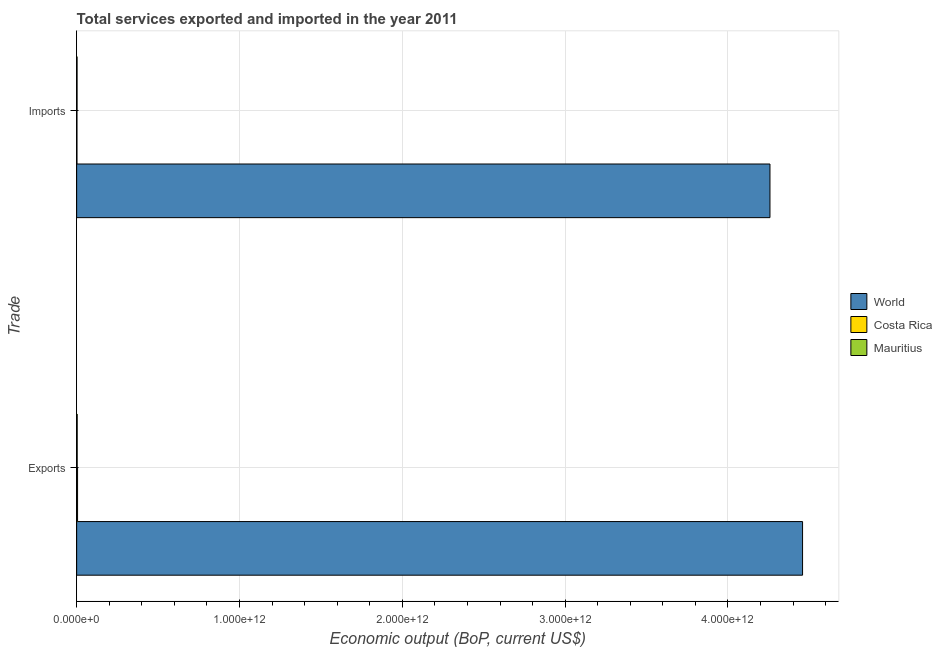Are the number of bars on each tick of the Y-axis equal?
Your response must be concise. Yes. How many bars are there on the 1st tick from the bottom?
Provide a short and direct response. 3. What is the label of the 1st group of bars from the top?
Provide a succinct answer. Imports. What is the amount of service imports in Costa Rica?
Your answer should be very brief. 1.82e+09. Across all countries, what is the maximum amount of service exports?
Ensure brevity in your answer.  4.46e+12. Across all countries, what is the minimum amount of service exports?
Your answer should be compact. 3.26e+09. In which country was the amount of service exports minimum?
Your answer should be very brief. Mauritius. What is the total amount of service exports in the graph?
Your response must be concise. 4.47e+12. What is the difference between the amount of service imports in Mauritius and that in Costa Rica?
Your answer should be compact. 6.49e+08. What is the difference between the amount of service exports in World and the amount of service imports in Mauritius?
Offer a terse response. 4.46e+12. What is the average amount of service imports per country?
Keep it short and to the point. 1.42e+12. What is the difference between the amount of service imports and amount of service exports in World?
Provide a succinct answer. -2.00e+11. In how many countries, is the amount of service imports greater than 4000000000000 US$?
Ensure brevity in your answer.  1. What is the ratio of the amount of service imports in World to that in Mauritius?
Offer a very short reply. 1723.81. In how many countries, is the amount of service exports greater than the average amount of service exports taken over all countries?
Make the answer very short. 1. What does the 2nd bar from the top in Imports represents?
Keep it short and to the point. Costa Rica. What does the 3rd bar from the bottom in Imports represents?
Keep it short and to the point. Mauritius. How many bars are there?
Provide a short and direct response. 6. Are all the bars in the graph horizontal?
Ensure brevity in your answer.  Yes. How many countries are there in the graph?
Offer a terse response. 3. What is the difference between two consecutive major ticks on the X-axis?
Provide a succinct answer. 1.00e+12. Are the values on the major ticks of X-axis written in scientific E-notation?
Make the answer very short. Yes. Where does the legend appear in the graph?
Your response must be concise. Center right. How many legend labels are there?
Make the answer very short. 3. What is the title of the graph?
Your answer should be compact. Total services exported and imported in the year 2011. Does "Philippines" appear as one of the legend labels in the graph?
Offer a terse response. No. What is the label or title of the X-axis?
Give a very brief answer. Economic output (BoP, current US$). What is the label or title of the Y-axis?
Offer a very short reply. Trade. What is the Economic output (BoP, current US$) in World in Exports?
Offer a very short reply. 4.46e+12. What is the Economic output (BoP, current US$) of Costa Rica in Exports?
Ensure brevity in your answer.  5.52e+09. What is the Economic output (BoP, current US$) in Mauritius in Exports?
Offer a terse response. 3.26e+09. What is the Economic output (BoP, current US$) in World in Imports?
Provide a short and direct response. 4.26e+12. What is the Economic output (BoP, current US$) of Costa Rica in Imports?
Offer a terse response. 1.82e+09. What is the Economic output (BoP, current US$) of Mauritius in Imports?
Your response must be concise. 2.47e+09. Across all Trade, what is the maximum Economic output (BoP, current US$) in World?
Make the answer very short. 4.46e+12. Across all Trade, what is the maximum Economic output (BoP, current US$) of Costa Rica?
Ensure brevity in your answer.  5.52e+09. Across all Trade, what is the maximum Economic output (BoP, current US$) in Mauritius?
Make the answer very short. 3.26e+09. Across all Trade, what is the minimum Economic output (BoP, current US$) in World?
Your response must be concise. 4.26e+12. Across all Trade, what is the minimum Economic output (BoP, current US$) in Costa Rica?
Keep it short and to the point. 1.82e+09. Across all Trade, what is the minimum Economic output (BoP, current US$) in Mauritius?
Your answer should be compact. 2.47e+09. What is the total Economic output (BoP, current US$) in World in the graph?
Make the answer very short. 8.72e+12. What is the total Economic output (BoP, current US$) in Costa Rica in the graph?
Your answer should be compact. 7.34e+09. What is the total Economic output (BoP, current US$) in Mauritius in the graph?
Offer a very short reply. 5.73e+09. What is the difference between the Economic output (BoP, current US$) of World in Exports and that in Imports?
Offer a terse response. 2.00e+11. What is the difference between the Economic output (BoP, current US$) in Costa Rica in Exports and that in Imports?
Keep it short and to the point. 3.70e+09. What is the difference between the Economic output (BoP, current US$) in Mauritius in Exports and that in Imports?
Offer a very short reply. 7.91e+08. What is the difference between the Economic output (BoP, current US$) in World in Exports and the Economic output (BoP, current US$) in Costa Rica in Imports?
Give a very brief answer. 4.46e+12. What is the difference between the Economic output (BoP, current US$) of World in Exports and the Economic output (BoP, current US$) of Mauritius in Imports?
Provide a short and direct response. 4.46e+12. What is the difference between the Economic output (BoP, current US$) of Costa Rica in Exports and the Economic output (BoP, current US$) of Mauritius in Imports?
Keep it short and to the point. 3.05e+09. What is the average Economic output (BoP, current US$) of World per Trade?
Provide a succinct answer. 4.36e+12. What is the average Economic output (BoP, current US$) in Costa Rica per Trade?
Provide a succinct answer. 3.67e+09. What is the average Economic output (BoP, current US$) of Mauritius per Trade?
Ensure brevity in your answer.  2.87e+09. What is the difference between the Economic output (BoP, current US$) in World and Economic output (BoP, current US$) in Costa Rica in Exports?
Ensure brevity in your answer.  4.45e+12. What is the difference between the Economic output (BoP, current US$) in World and Economic output (BoP, current US$) in Mauritius in Exports?
Your answer should be very brief. 4.45e+12. What is the difference between the Economic output (BoP, current US$) in Costa Rica and Economic output (BoP, current US$) in Mauritius in Exports?
Your response must be concise. 2.26e+09. What is the difference between the Economic output (BoP, current US$) of World and Economic output (BoP, current US$) of Costa Rica in Imports?
Provide a succinct answer. 4.26e+12. What is the difference between the Economic output (BoP, current US$) of World and Economic output (BoP, current US$) of Mauritius in Imports?
Keep it short and to the point. 4.26e+12. What is the difference between the Economic output (BoP, current US$) in Costa Rica and Economic output (BoP, current US$) in Mauritius in Imports?
Offer a very short reply. -6.49e+08. What is the ratio of the Economic output (BoP, current US$) of World in Exports to that in Imports?
Your answer should be very brief. 1.05. What is the ratio of the Economic output (BoP, current US$) of Costa Rica in Exports to that in Imports?
Provide a short and direct response. 3.03. What is the ratio of the Economic output (BoP, current US$) in Mauritius in Exports to that in Imports?
Provide a short and direct response. 1.32. What is the difference between the highest and the second highest Economic output (BoP, current US$) in World?
Provide a short and direct response. 2.00e+11. What is the difference between the highest and the second highest Economic output (BoP, current US$) in Costa Rica?
Your answer should be compact. 3.70e+09. What is the difference between the highest and the second highest Economic output (BoP, current US$) of Mauritius?
Offer a very short reply. 7.91e+08. What is the difference between the highest and the lowest Economic output (BoP, current US$) of World?
Offer a terse response. 2.00e+11. What is the difference between the highest and the lowest Economic output (BoP, current US$) of Costa Rica?
Offer a very short reply. 3.70e+09. What is the difference between the highest and the lowest Economic output (BoP, current US$) in Mauritius?
Keep it short and to the point. 7.91e+08. 